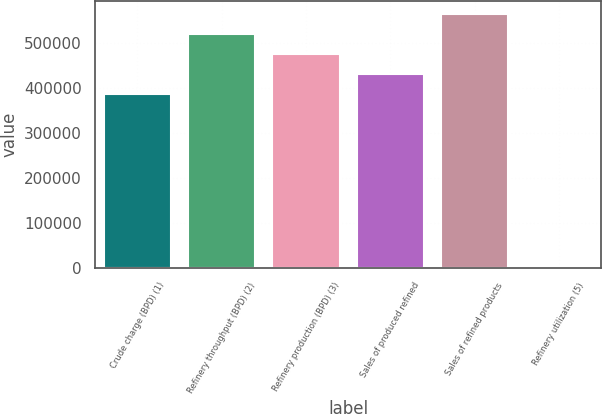Convert chart to OTSL. <chart><loc_0><loc_0><loc_500><loc_500><bar_chart><fcel>Crude charge (BPD) (1)<fcel>Refinery throughput (BPD) (2)<fcel>Refinery production (BPD) (3)<fcel>Sales of produced refined<fcel>Sales of refined products<fcel>Refinery utilization (5)<nl><fcel>387520<fcel>521411<fcel>476780<fcel>432150<fcel>566041<fcel>87.5<nl></chart> 